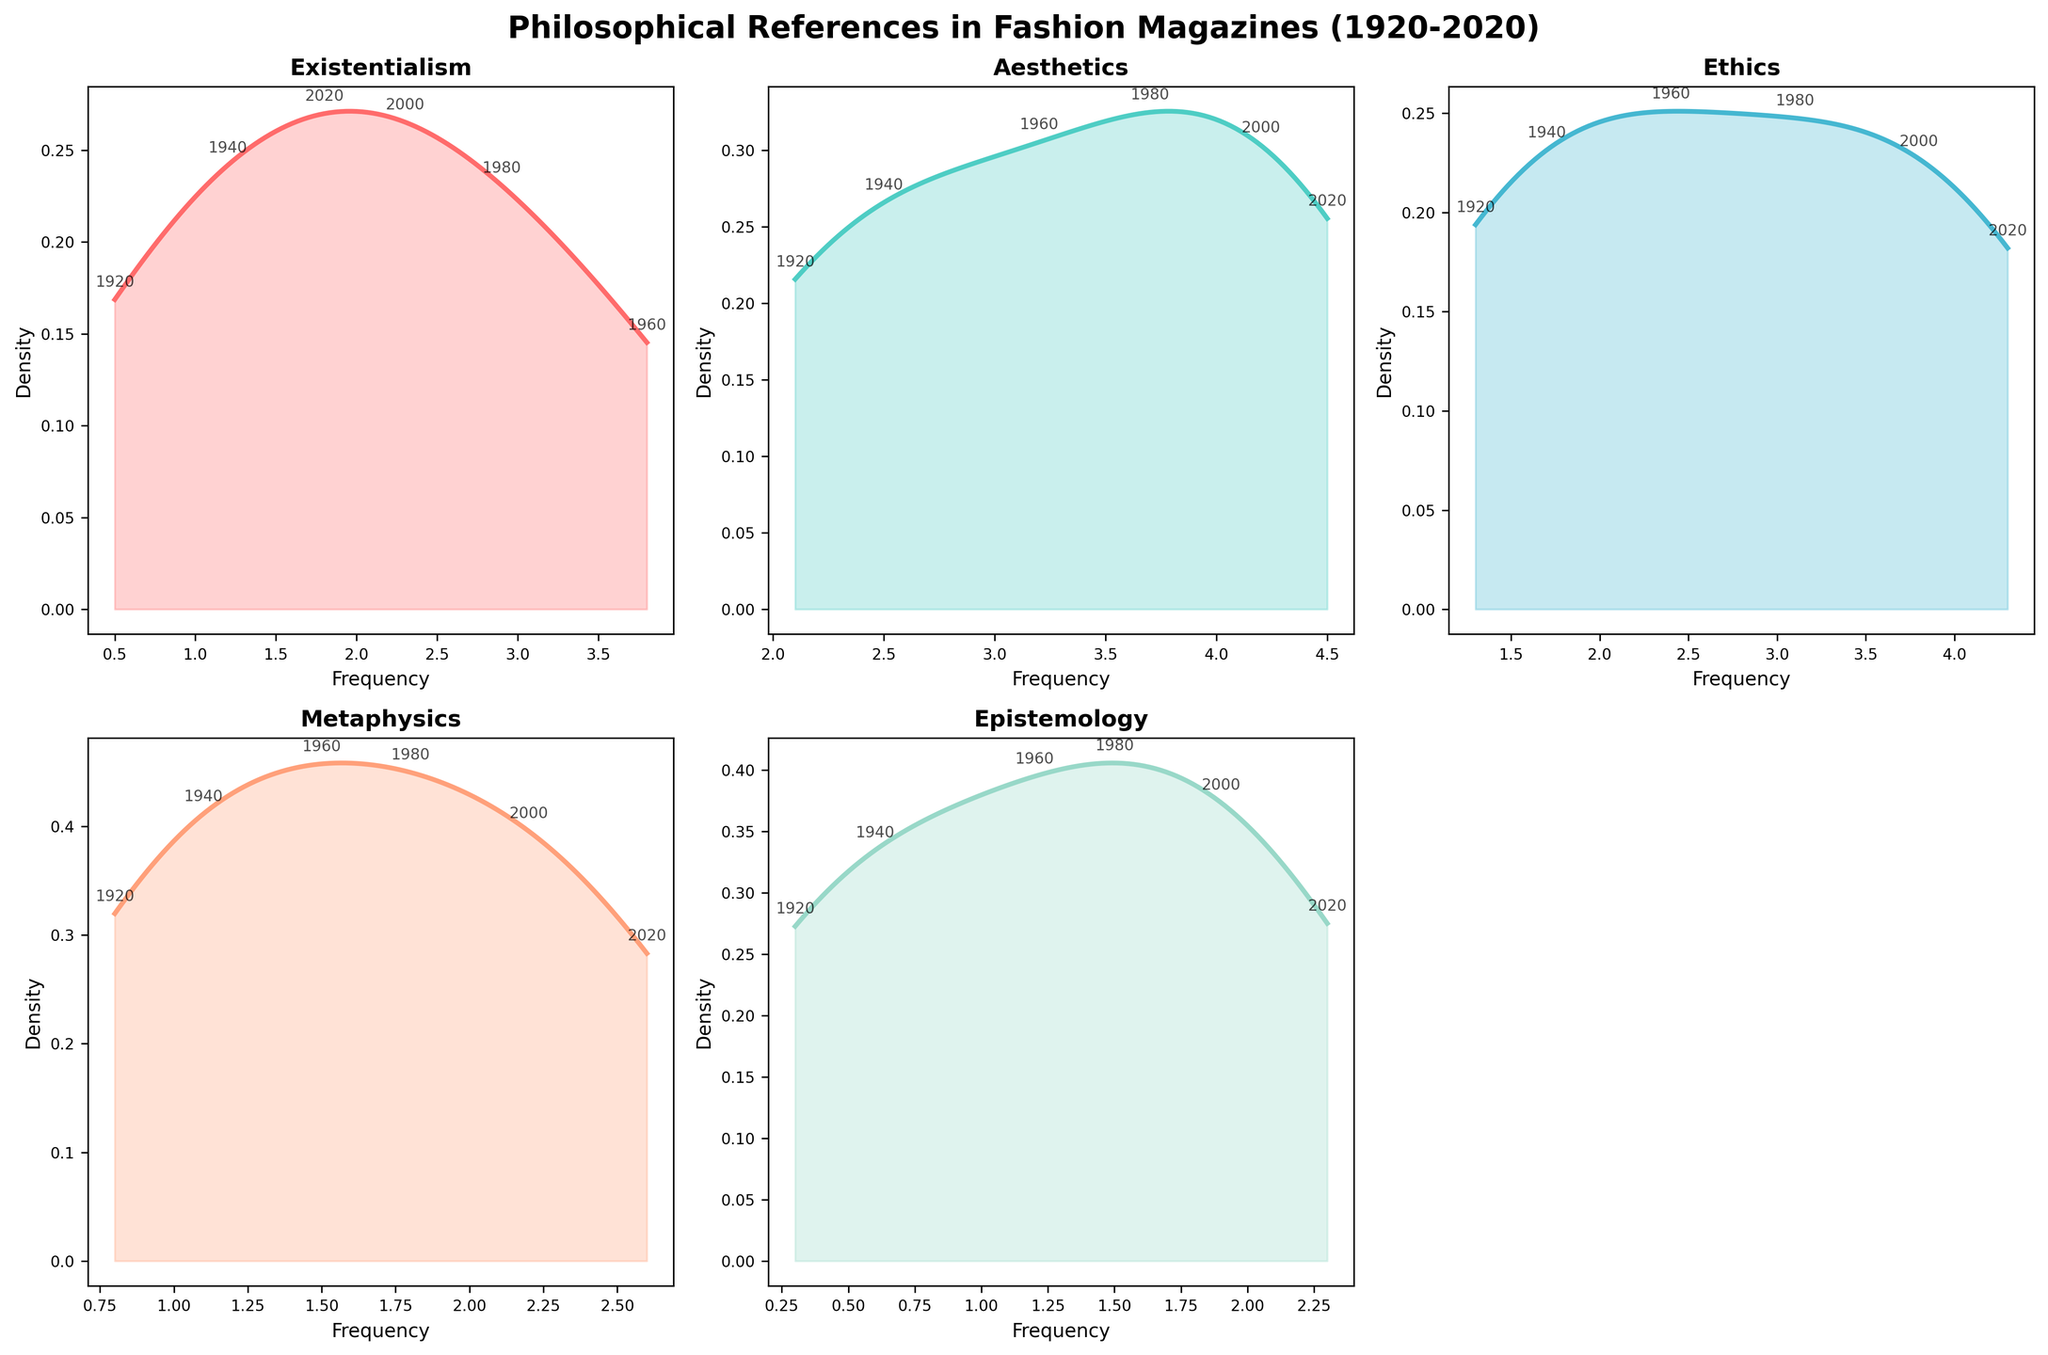what is the title of the figure? The title is displayed at the top of the figure and provides a summary of what the figure is about. For this figure, the title is prominently placed at the top, in bold and larger font size.
Answer: Philosophical References in Fashion Magazines (1920-2020) Which philosophical reference had the highest frequency in 2020? To determine this, examine the annotations for 2020 across all subplots and compare the frequencies marked for each philosophy.
Answer: Aesthetics What is the trend in the frequency of metaphysics over the past century? Look at the placement and connection of the data points for metaphysics across the years on the plot. Note how the values change from 1920 to 2020.
Answer: Increasing Between which years does existentialism have the highest increase in frequency? Identify and compare the values for existentialism at different years, noting the increment between consecutive years; the highest increase will be between the years with the biggest difference.
Answer: 1940 to 1960 How do the frequencies of ethics in 2000 compare to those in 1980? Locate the annotations for ethics in the years 2000 and 1980 within its subplot. Compare the frequency values of these two years to determine the difference.
Answer: Higher in 2000 Which philosophical reference shows the least variation across the years? Compare the range of frequencies for each philosophical reference over the years. The one with the smallest range indicates the least variation.
Answer: Epistemology How does the frequency of aesthetics change from 1940 to 2000? Note the values of aesthetics in 1940 and 2000. Compare these two values to understand the change over time.
Answer: Increases Which philosophical references had their peak frequency in 1980? Check the peak values indicated in 1980 for each subplot and determine which philosophies reached their highest frequency that year.
Answer: Metaphysics, Ethics Compare the density plot shapes of epistemology and existentialism. Examine the bandwidth and form of the density plots for both epistemology and existentialism to identify similarities or differences in their shapes.
Answer: Epistemology is narrower, while existentialism is broader What is the frequency of aesthetics in the year 1920? Locate the data point for the year 1920 in the subplot for aesthetics and read the annotated frequency value for that year.
Answer: 2.1 